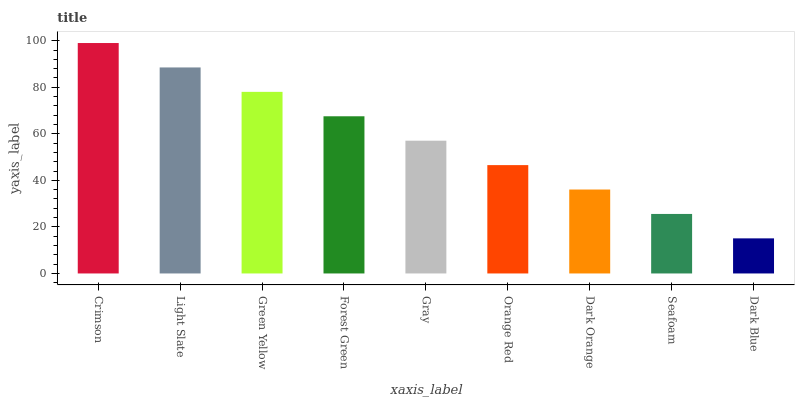Is Dark Blue the minimum?
Answer yes or no. Yes. Is Crimson the maximum?
Answer yes or no. Yes. Is Light Slate the minimum?
Answer yes or no. No. Is Light Slate the maximum?
Answer yes or no. No. Is Crimson greater than Light Slate?
Answer yes or no. Yes. Is Light Slate less than Crimson?
Answer yes or no. Yes. Is Light Slate greater than Crimson?
Answer yes or no. No. Is Crimson less than Light Slate?
Answer yes or no. No. Is Gray the high median?
Answer yes or no. Yes. Is Gray the low median?
Answer yes or no. Yes. Is Orange Red the high median?
Answer yes or no. No. Is Seafoam the low median?
Answer yes or no. No. 